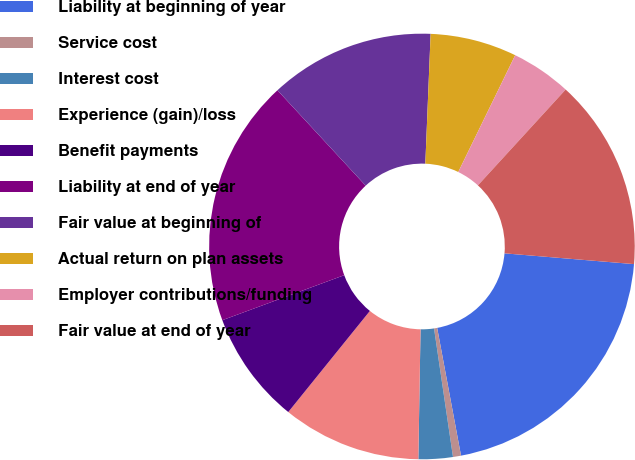<chart> <loc_0><loc_0><loc_500><loc_500><pie_chart><fcel>Liability at beginning of year<fcel>Service cost<fcel>Interest cost<fcel>Experience (gain)/loss<fcel>Benefit payments<fcel>Liability at end of year<fcel>Fair value at beginning of<fcel>Actual return on plan assets<fcel>Employer contributions/funding<fcel>Fair value at end of year<nl><fcel>20.74%<fcel>0.61%<fcel>2.6%<fcel>10.54%<fcel>8.56%<fcel>18.75%<fcel>12.53%<fcel>6.57%<fcel>4.58%<fcel>14.52%<nl></chart> 